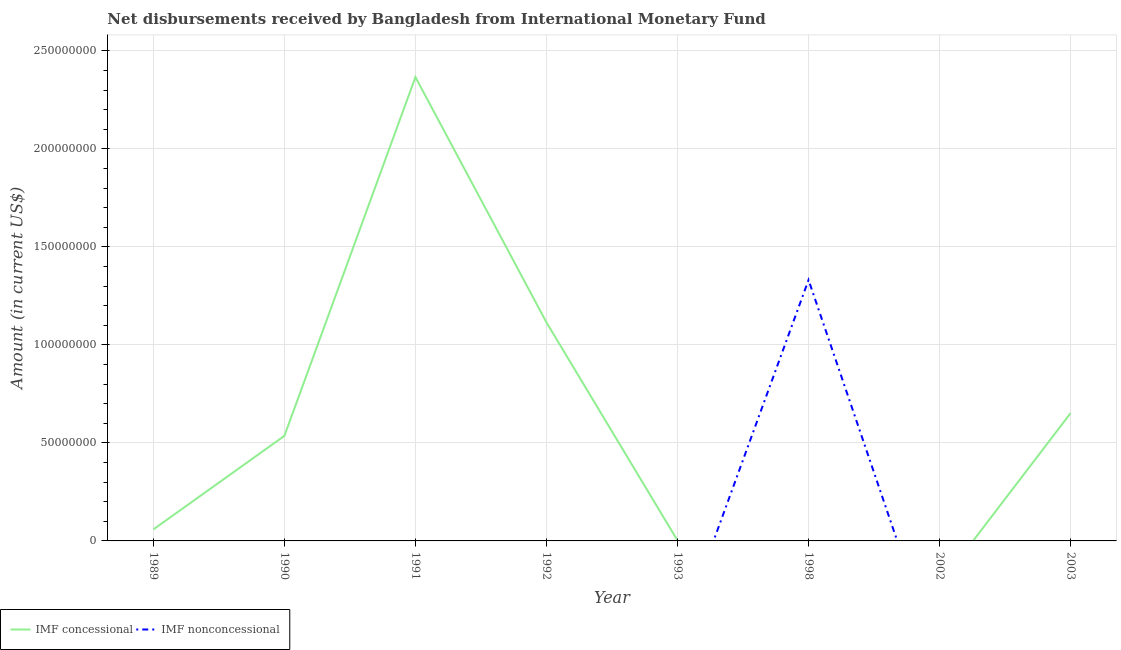How many different coloured lines are there?
Keep it short and to the point. 2. What is the net non concessional disbursements from imf in 2003?
Provide a succinct answer. 0. Across all years, what is the maximum net non concessional disbursements from imf?
Offer a very short reply. 1.33e+08. Across all years, what is the minimum net non concessional disbursements from imf?
Keep it short and to the point. 0. In which year was the net non concessional disbursements from imf maximum?
Your answer should be very brief. 1998. What is the total net concessional disbursements from imf in the graph?
Your response must be concise. 4.73e+08. What is the difference between the net concessional disbursements from imf in 1990 and that in 2003?
Keep it short and to the point. -1.16e+07. What is the difference between the net non concessional disbursements from imf in 2002 and the net concessional disbursements from imf in 1992?
Make the answer very short. -1.11e+08. What is the average net non concessional disbursements from imf per year?
Provide a succinct answer. 1.66e+07. In how many years, is the net concessional disbursements from imf greater than 190000000 US$?
Make the answer very short. 1. What is the difference between the highest and the second highest net concessional disbursements from imf?
Offer a very short reply. 1.25e+08. What is the difference between the highest and the lowest net non concessional disbursements from imf?
Provide a succinct answer. 1.33e+08. Does the net non concessional disbursements from imf monotonically increase over the years?
Make the answer very short. No. How many lines are there?
Ensure brevity in your answer.  2. What is the difference between two consecutive major ticks on the Y-axis?
Keep it short and to the point. 5.00e+07. Where does the legend appear in the graph?
Offer a terse response. Bottom left. How many legend labels are there?
Provide a short and direct response. 2. What is the title of the graph?
Provide a succinct answer. Net disbursements received by Bangladesh from International Monetary Fund. What is the label or title of the Y-axis?
Provide a succinct answer. Amount (in current US$). What is the Amount (in current US$) of IMF concessional in 1989?
Your response must be concise. 5.87e+06. What is the Amount (in current US$) of IMF nonconcessional in 1989?
Provide a succinct answer. 0. What is the Amount (in current US$) of IMF concessional in 1990?
Your answer should be very brief. 5.36e+07. What is the Amount (in current US$) of IMF nonconcessional in 1990?
Offer a very short reply. 0. What is the Amount (in current US$) of IMF concessional in 1991?
Keep it short and to the point. 2.37e+08. What is the Amount (in current US$) in IMF concessional in 1992?
Your answer should be compact. 1.11e+08. What is the Amount (in current US$) of IMF concessional in 1993?
Your answer should be compact. 2.14e+05. What is the Amount (in current US$) in IMF nonconcessional in 1993?
Provide a succinct answer. 0. What is the Amount (in current US$) in IMF nonconcessional in 1998?
Your response must be concise. 1.33e+08. What is the Amount (in current US$) in IMF concessional in 2002?
Your answer should be compact. 0. What is the Amount (in current US$) in IMF concessional in 2003?
Make the answer very short. 6.52e+07. Across all years, what is the maximum Amount (in current US$) in IMF concessional?
Offer a very short reply. 2.37e+08. Across all years, what is the maximum Amount (in current US$) of IMF nonconcessional?
Your response must be concise. 1.33e+08. Across all years, what is the minimum Amount (in current US$) of IMF concessional?
Ensure brevity in your answer.  0. Across all years, what is the minimum Amount (in current US$) in IMF nonconcessional?
Your answer should be very brief. 0. What is the total Amount (in current US$) in IMF concessional in the graph?
Keep it short and to the point. 4.73e+08. What is the total Amount (in current US$) in IMF nonconcessional in the graph?
Offer a terse response. 1.33e+08. What is the difference between the Amount (in current US$) of IMF concessional in 1989 and that in 1990?
Your answer should be very brief. -4.77e+07. What is the difference between the Amount (in current US$) in IMF concessional in 1989 and that in 1991?
Your answer should be compact. -2.31e+08. What is the difference between the Amount (in current US$) of IMF concessional in 1989 and that in 1992?
Keep it short and to the point. -1.06e+08. What is the difference between the Amount (in current US$) in IMF concessional in 1989 and that in 1993?
Ensure brevity in your answer.  5.66e+06. What is the difference between the Amount (in current US$) in IMF concessional in 1989 and that in 2003?
Offer a terse response. -5.94e+07. What is the difference between the Amount (in current US$) of IMF concessional in 1990 and that in 1991?
Offer a terse response. -1.83e+08. What is the difference between the Amount (in current US$) of IMF concessional in 1990 and that in 1992?
Offer a terse response. -5.79e+07. What is the difference between the Amount (in current US$) of IMF concessional in 1990 and that in 1993?
Provide a succinct answer. 5.34e+07. What is the difference between the Amount (in current US$) of IMF concessional in 1990 and that in 2003?
Offer a terse response. -1.16e+07. What is the difference between the Amount (in current US$) in IMF concessional in 1991 and that in 1992?
Offer a terse response. 1.25e+08. What is the difference between the Amount (in current US$) in IMF concessional in 1991 and that in 1993?
Offer a very short reply. 2.36e+08. What is the difference between the Amount (in current US$) in IMF concessional in 1991 and that in 2003?
Your answer should be compact. 1.71e+08. What is the difference between the Amount (in current US$) in IMF concessional in 1992 and that in 1993?
Provide a succinct answer. 1.11e+08. What is the difference between the Amount (in current US$) of IMF concessional in 1992 and that in 2003?
Your answer should be very brief. 4.62e+07. What is the difference between the Amount (in current US$) in IMF concessional in 1993 and that in 2003?
Your response must be concise. -6.50e+07. What is the difference between the Amount (in current US$) in IMF concessional in 1989 and the Amount (in current US$) in IMF nonconcessional in 1998?
Ensure brevity in your answer.  -1.27e+08. What is the difference between the Amount (in current US$) of IMF concessional in 1990 and the Amount (in current US$) of IMF nonconcessional in 1998?
Ensure brevity in your answer.  -7.95e+07. What is the difference between the Amount (in current US$) of IMF concessional in 1991 and the Amount (in current US$) of IMF nonconcessional in 1998?
Make the answer very short. 1.03e+08. What is the difference between the Amount (in current US$) in IMF concessional in 1992 and the Amount (in current US$) in IMF nonconcessional in 1998?
Your response must be concise. -2.17e+07. What is the difference between the Amount (in current US$) of IMF concessional in 1993 and the Amount (in current US$) of IMF nonconcessional in 1998?
Provide a succinct answer. -1.33e+08. What is the average Amount (in current US$) of IMF concessional per year?
Provide a short and direct response. 5.91e+07. What is the average Amount (in current US$) in IMF nonconcessional per year?
Provide a short and direct response. 1.66e+07. What is the ratio of the Amount (in current US$) of IMF concessional in 1989 to that in 1990?
Offer a terse response. 0.11. What is the ratio of the Amount (in current US$) of IMF concessional in 1989 to that in 1991?
Offer a very short reply. 0.02. What is the ratio of the Amount (in current US$) of IMF concessional in 1989 to that in 1992?
Make the answer very short. 0.05. What is the ratio of the Amount (in current US$) in IMF concessional in 1989 to that in 1993?
Offer a very short reply. 27.43. What is the ratio of the Amount (in current US$) of IMF concessional in 1989 to that in 2003?
Keep it short and to the point. 0.09. What is the ratio of the Amount (in current US$) in IMF concessional in 1990 to that in 1991?
Make the answer very short. 0.23. What is the ratio of the Amount (in current US$) of IMF concessional in 1990 to that in 1992?
Offer a very short reply. 0.48. What is the ratio of the Amount (in current US$) of IMF concessional in 1990 to that in 1993?
Provide a succinct answer. 250.45. What is the ratio of the Amount (in current US$) of IMF concessional in 1990 to that in 2003?
Keep it short and to the point. 0.82. What is the ratio of the Amount (in current US$) of IMF concessional in 1991 to that in 1992?
Your answer should be very brief. 2.12. What is the ratio of the Amount (in current US$) of IMF concessional in 1991 to that in 1993?
Your answer should be compact. 1105.72. What is the ratio of the Amount (in current US$) of IMF concessional in 1991 to that in 2003?
Provide a short and direct response. 3.63. What is the ratio of the Amount (in current US$) of IMF concessional in 1992 to that in 1993?
Ensure brevity in your answer.  520.86. What is the ratio of the Amount (in current US$) in IMF concessional in 1992 to that in 2003?
Your response must be concise. 1.71. What is the ratio of the Amount (in current US$) of IMF concessional in 1993 to that in 2003?
Give a very brief answer. 0. What is the difference between the highest and the second highest Amount (in current US$) of IMF concessional?
Keep it short and to the point. 1.25e+08. What is the difference between the highest and the lowest Amount (in current US$) of IMF concessional?
Your answer should be compact. 2.37e+08. What is the difference between the highest and the lowest Amount (in current US$) of IMF nonconcessional?
Your response must be concise. 1.33e+08. 